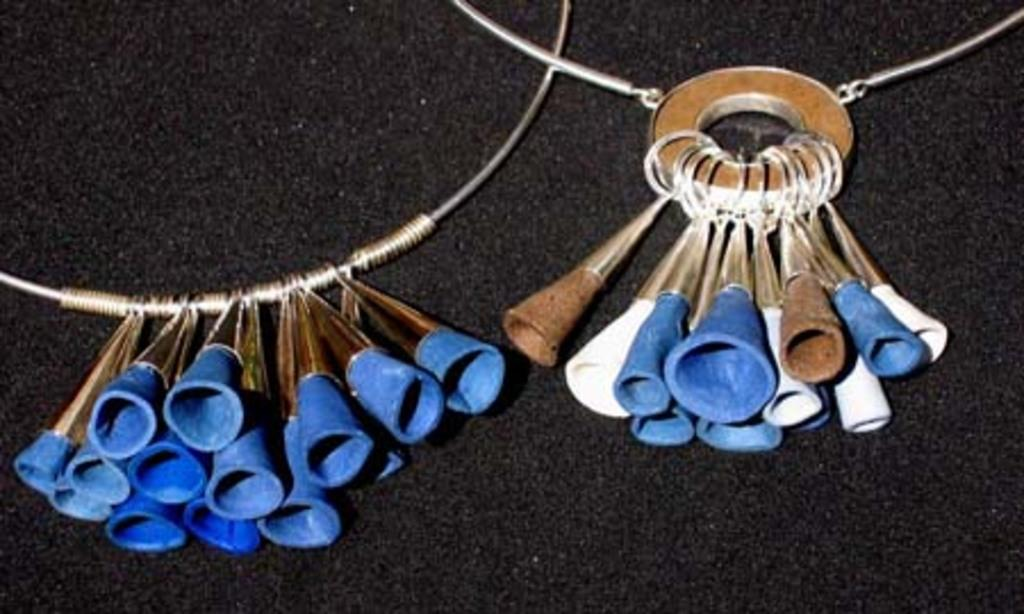What objects are present in the image? There are ornaments in the image. What is the color of the surface on which the ornaments are placed? The ornaments are on a black surface. What type of arch can be seen in the image? There is no arch present in the image; it only features ornaments on a black surface. 